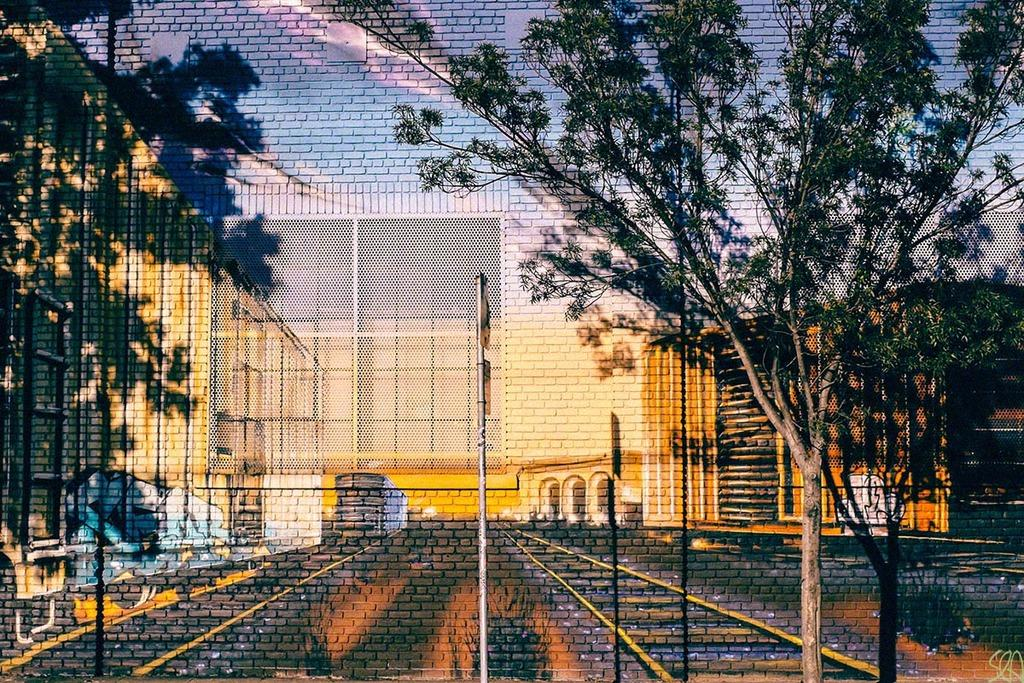What type of artwork is depicted in the image? The image appears to be a 3D wall painting. What transportation-related feature is shown in the painting? There are rail tracks depicted in the painting. What type of barrier is shown in the painting? There is a fence depicted in the painting. What type of structures are shown in the painting? There are buildings depicted in the painting. What type of vegetation is shown in the painting? There are trees depicted in the painting. What type of signage is shown in the painting? There is a pole with boards attached in the painting. Where is the shelf located in the painting? There is no shelf present in the painting; it only features rail tracks, a fence, buildings, trees, and a pole with boards attached. 